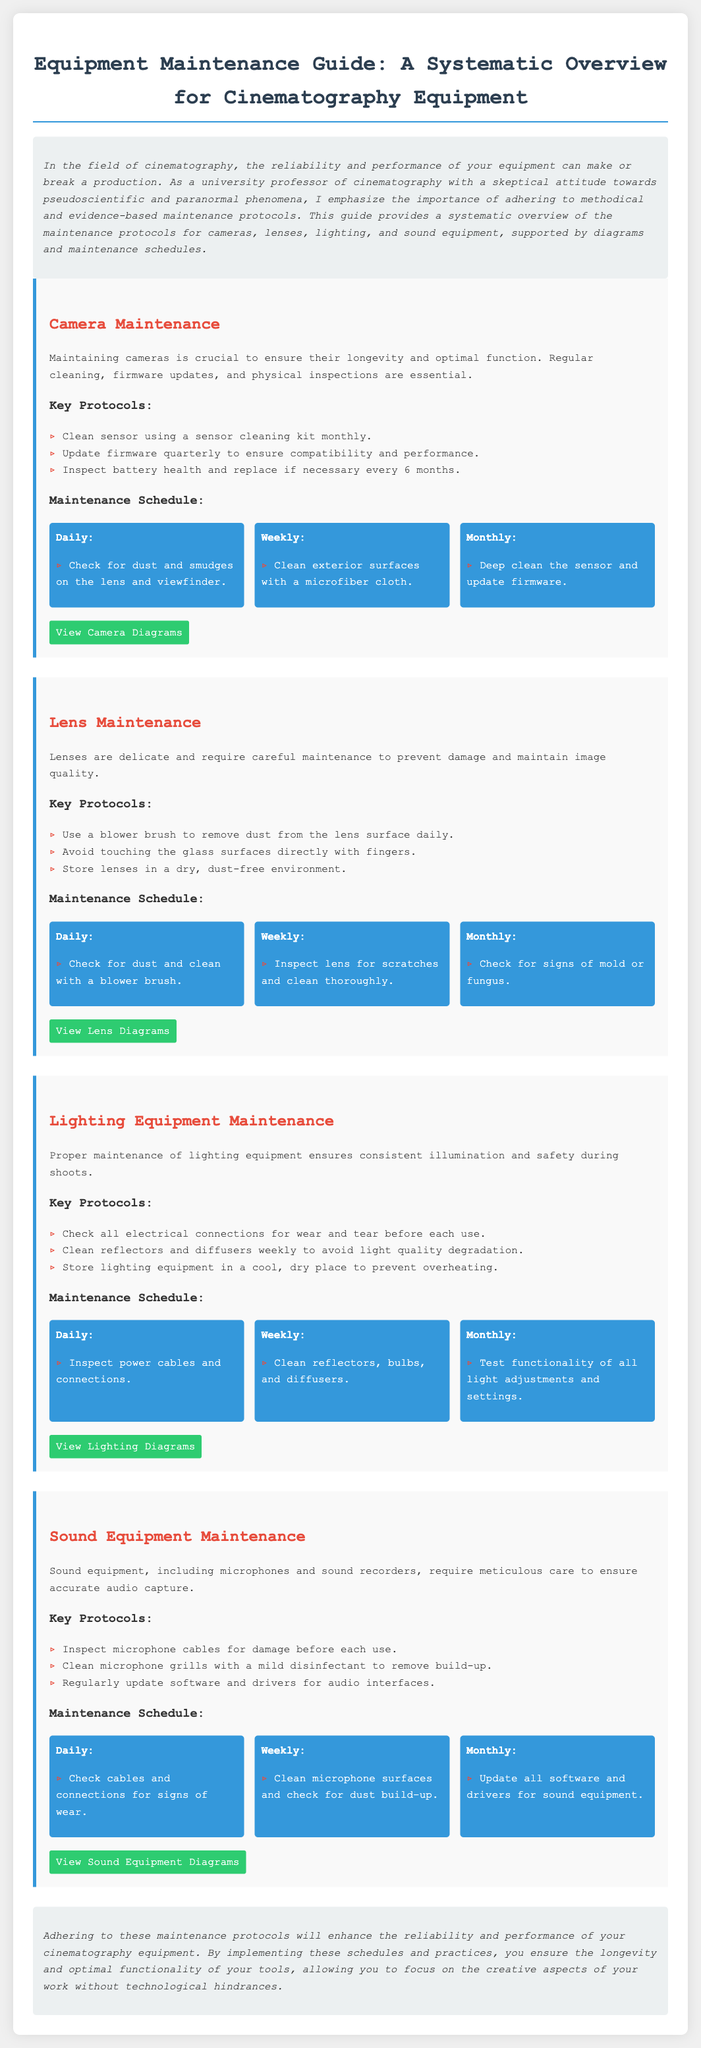what is the title of the document? The title is explicitly mentioned in the header section of the document.
Answer: Equipment Maintenance Guide: A Systematic Overview for Cinematography Equipment how often should camera firmware be updated? The document specifies that firmware should be updated on a quarterly basis.
Answer: quarterly what should be checked daily for sound equipment maintenance? The document outlines daily checks for sound equipment, stating to check cables and connections for signs of wear.
Answer: cables and connections what is the main focus of the introduction section? The introduction emphasizes the significance of methodical and evidence-based maintenance protocols for cinematography equipment.
Answer: methodical and evidence-based maintenance how often should lenses be inspected for scratches? The maintenance schedule for lenses indicates that they should be inspected weekly.
Answer: weekly what should be cleaned weekly on lighting equipment? The document specifies that reflectors, bulbs, and diffusers should be cleaned weekly.
Answer: reflectors, bulbs, and diffusers what common theme do the maintenance schedules for all equipment share? All equipment maintenance schedules include daily, weekly, and monthly tasks for upkeep.
Answer: daily, weekly, and monthly tasks what is the recommended storage condition for lenses? The lens maintenance section advises storing lenses in a dry, dust-free environment.
Answer: dry, dust-free environment 